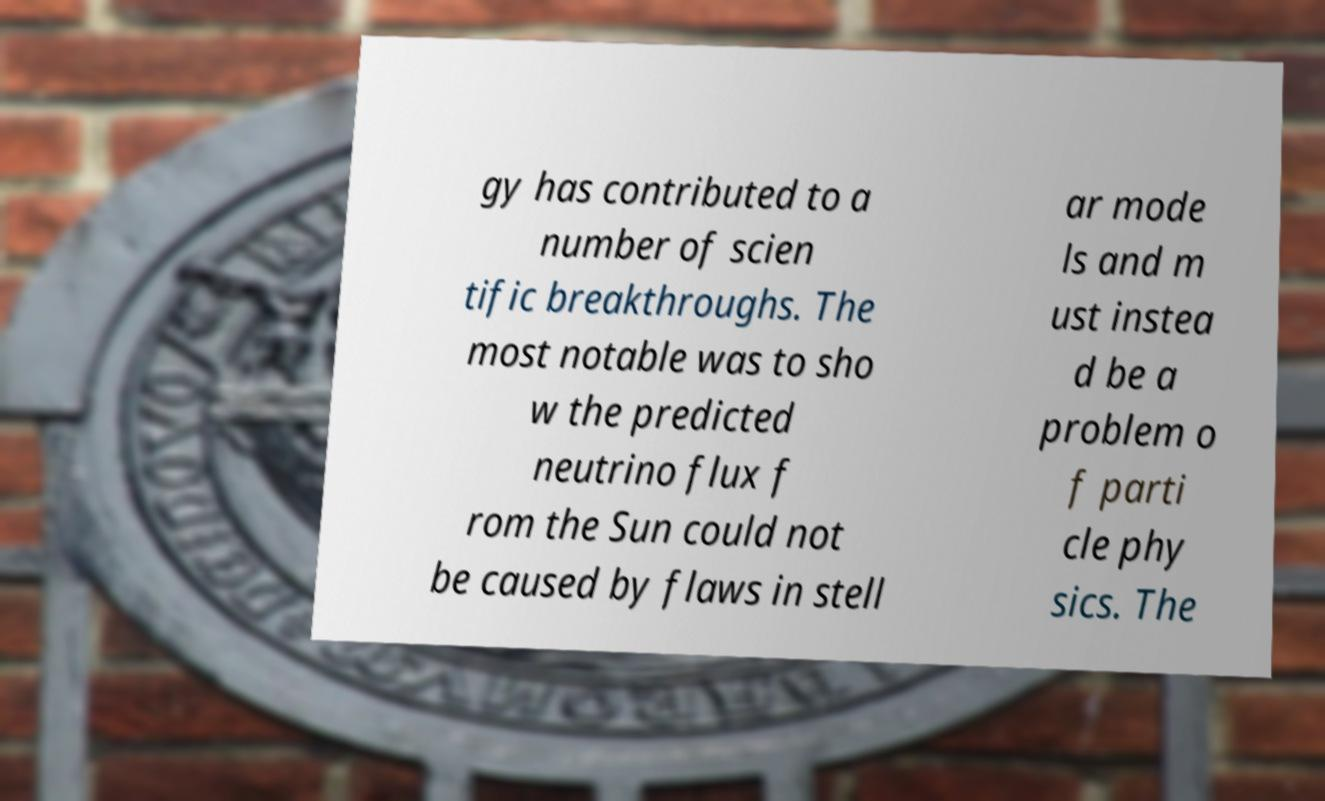I need the written content from this picture converted into text. Can you do that? gy has contributed to a number of scien tific breakthroughs. The most notable was to sho w the predicted neutrino flux f rom the Sun could not be caused by flaws in stell ar mode ls and m ust instea d be a problem o f parti cle phy sics. The 